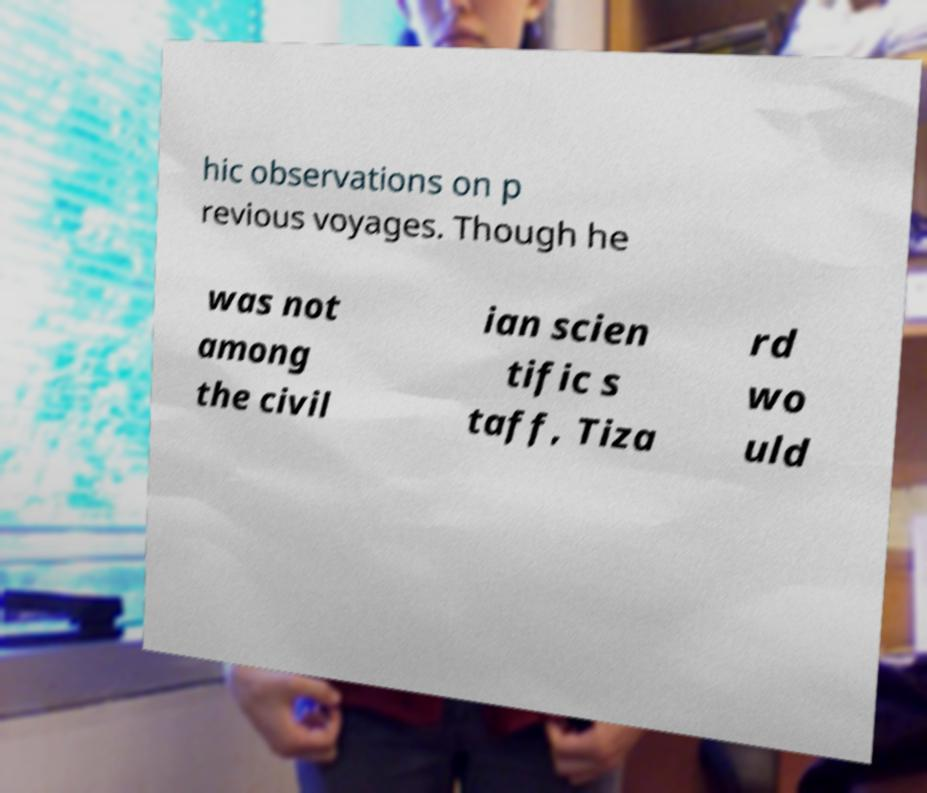Could you assist in decoding the text presented in this image and type it out clearly? hic observations on p revious voyages. Though he was not among the civil ian scien tific s taff, Tiza rd wo uld 